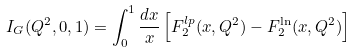Convert formula to latex. <formula><loc_0><loc_0><loc_500><loc_500>I _ { G } ( Q ^ { 2 } , 0 , 1 ) = \int _ { 0 } ^ { 1 } \frac { d x } { x } \left [ F _ { 2 } ^ { l p } ( x , Q ^ { 2 } ) - F _ { 2 } ^ { \ln } ( x , Q ^ { 2 } ) \right ]</formula> 